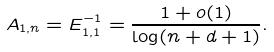<formula> <loc_0><loc_0><loc_500><loc_500>A _ { 1 , n } = E ^ { - 1 } _ { 1 , 1 } = \frac { 1 + o ( 1 ) } { \log ( n + d + 1 ) } .</formula> 